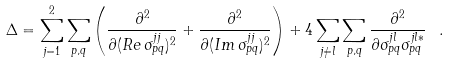<formula> <loc_0><loc_0><loc_500><loc_500>\Delta = \sum _ { j = 1 } ^ { 2 } \sum _ { p , q } \left ( \frac { \partial ^ { 2 } } { \partial ( R e \, \sigma _ { p q } ^ { j j } ) ^ { 2 } } + \frac { \partial ^ { 2 } } { \partial ( I m \, \sigma _ { p q } ^ { j j } ) ^ { 2 } } \right ) + 4 \sum _ { j \neq l } \sum _ { p , q } \frac { \partial ^ { 2 } } { \partial \sigma _ { p q } ^ { j l } \sigma _ { p q } ^ { j l * } } \ .</formula> 